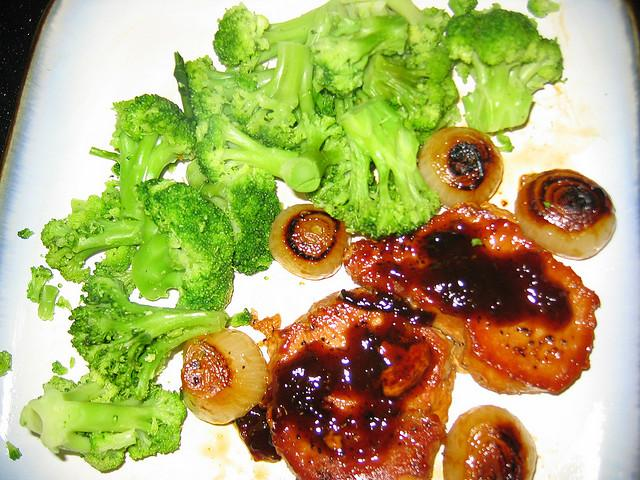What are the little round vegetables called? Please explain your reasoning. onions. It is easy to tell by the picture these are caramelized onions. 